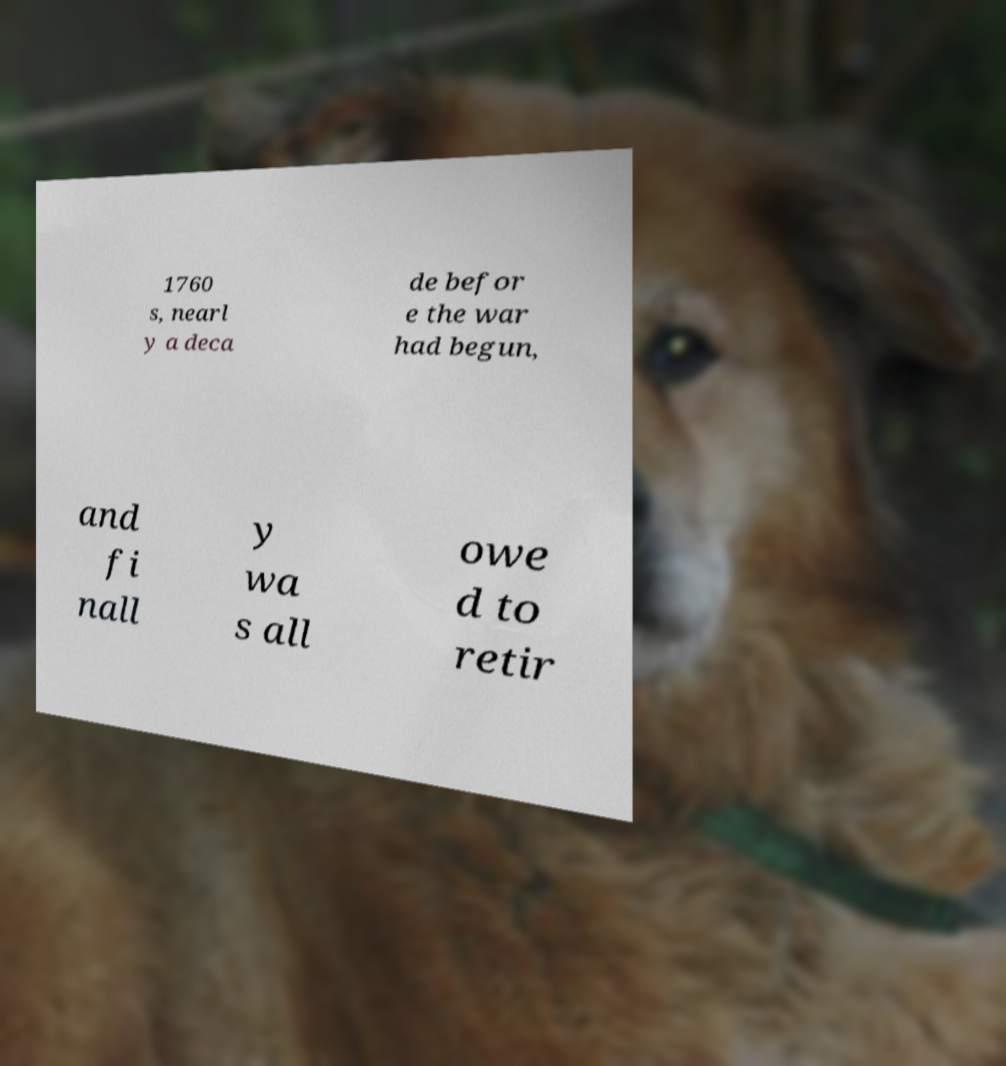For documentation purposes, I need the text within this image transcribed. Could you provide that? 1760 s, nearl y a deca de befor e the war had begun, and fi nall y wa s all owe d to retir 